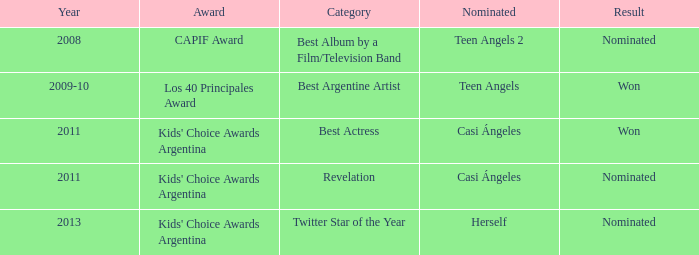In which year was teen angels 2 nominated? 2008.0. 